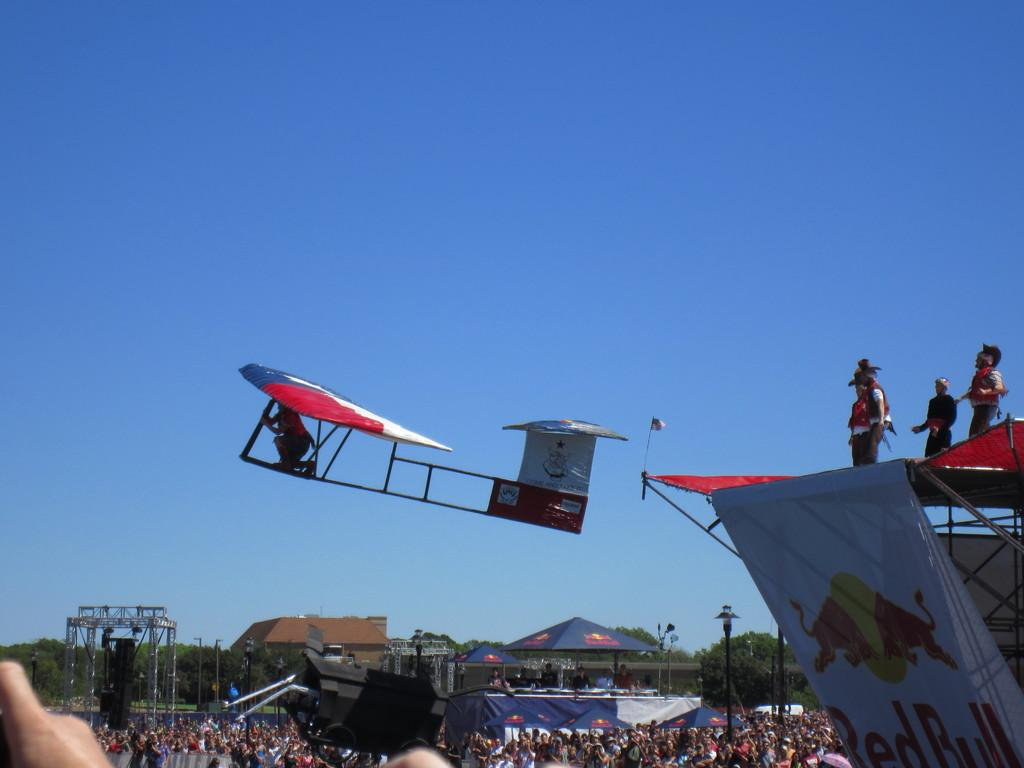<image>
Summarize the visual content of the image. An alternative aircraft show is sponsored by the Red Bull energy drink. 